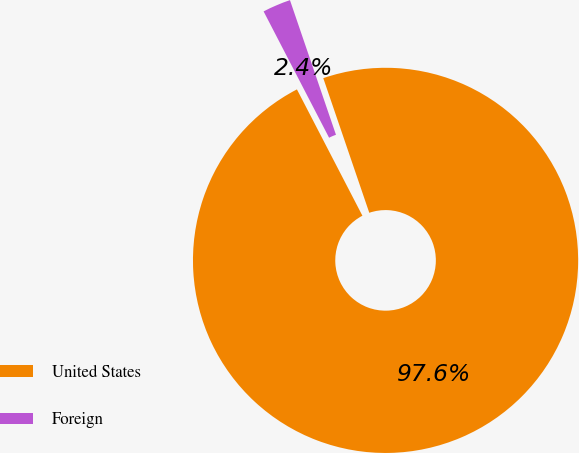<chart> <loc_0><loc_0><loc_500><loc_500><pie_chart><fcel>United States<fcel>Foreign<nl><fcel>97.63%<fcel>2.37%<nl></chart> 